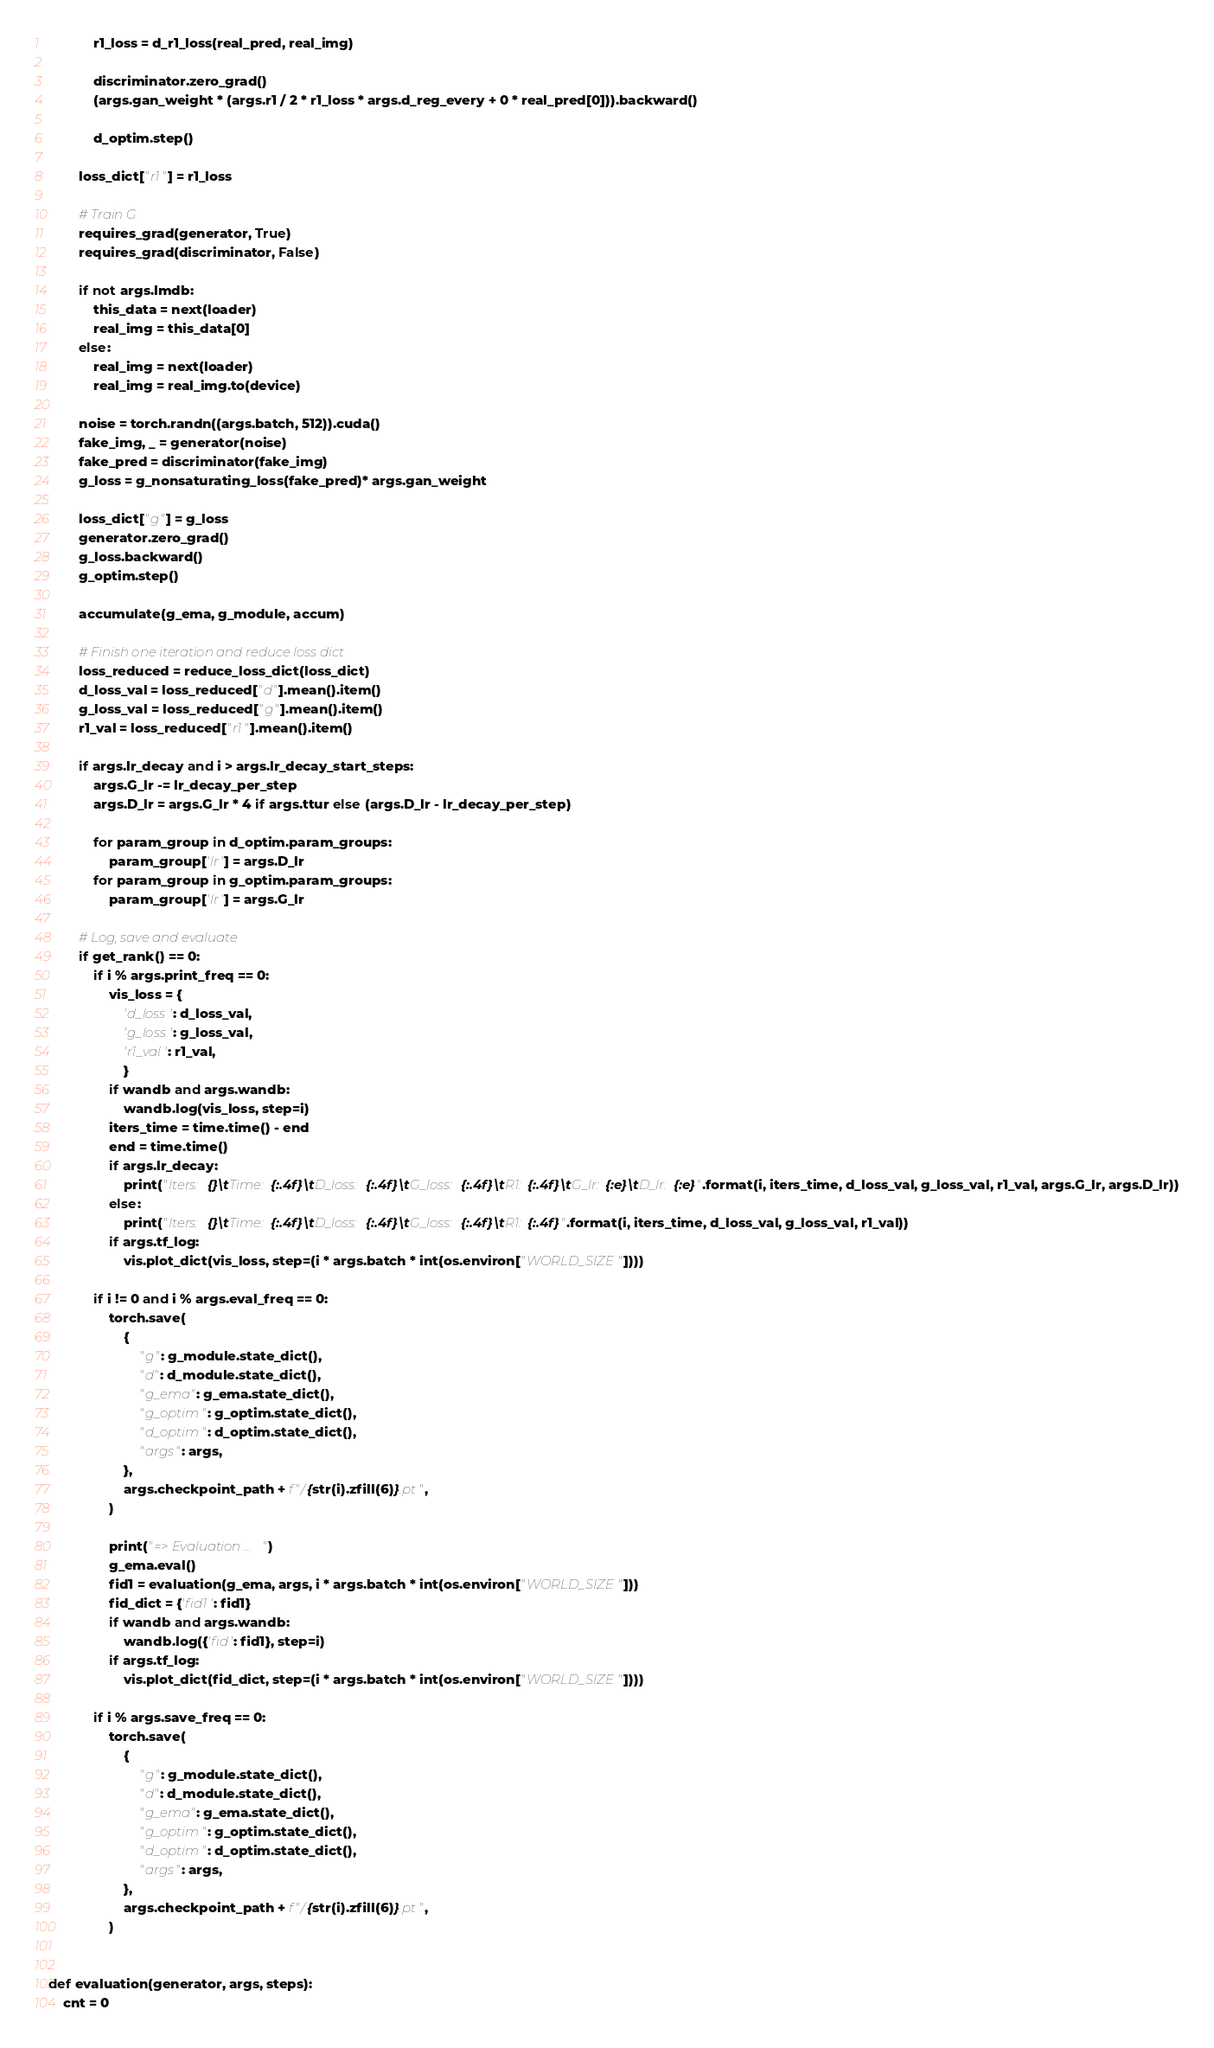<code> <loc_0><loc_0><loc_500><loc_500><_Python_>            r1_loss = d_r1_loss(real_pred, real_img)

            discriminator.zero_grad()
            (args.gan_weight * (args.r1 / 2 * r1_loss * args.d_reg_every + 0 * real_pred[0])).backward()

            d_optim.step()

        loss_dict["r1"] = r1_loss

        # Train G
        requires_grad(generator, True)
        requires_grad(discriminator, False)

        if not args.lmdb:
            this_data = next(loader)
            real_img = this_data[0]
        else:
            real_img = next(loader)
            real_img = real_img.to(device)

        noise = torch.randn((args.batch, 512)).cuda()
        fake_img, _ = generator(noise)
        fake_pred = discriminator(fake_img)
        g_loss = g_nonsaturating_loss(fake_pred)* args.gan_weight

        loss_dict["g"] = g_loss
        generator.zero_grad()
        g_loss.backward()
        g_optim.step()

        accumulate(g_ema, g_module, accum)

        # Finish one iteration and reduce loss dict
        loss_reduced = reduce_loss_dict(loss_dict)
        d_loss_val = loss_reduced["d"].mean().item()
        g_loss_val = loss_reduced["g"].mean().item()
        r1_val = loss_reduced["r1"].mean().item()

        if args.lr_decay and i > args.lr_decay_start_steps:
            args.G_lr -= lr_decay_per_step
            args.D_lr = args.G_lr * 4 if args.ttur else (args.D_lr - lr_decay_per_step)
        
            for param_group in d_optim.param_groups:
                param_group['lr'] = args.D_lr
            for param_group in g_optim.param_groups:
                param_group['lr'] = args.G_lr

        # Log, save and evaluate
        if get_rank() == 0:
            if i % args.print_freq == 0:
                vis_loss = {
                    'd_loss': d_loss_val,
                    'g_loss': g_loss_val,
                    'r1_val': r1_val,
                    }
                if wandb and args.wandb:
                    wandb.log(vis_loss, step=i)
                iters_time = time.time() - end
                end = time.time()
                if args.lr_decay:
                    print("Iters: {}\tTime: {:.4f}\tD_loss: {:.4f}\tG_loss: {:.4f}\tR1: {:.4f}\tG_lr: {:e}\tD_lr: {:e}".format(i, iters_time, d_loss_val, g_loss_val, r1_val, args.G_lr, args.D_lr))
                else:
                    print("Iters: {}\tTime: {:.4f}\tD_loss: {:.4f}\tG_loss: {:.4f}\tR1: {:.4f}".format(i, iters_time, d_loss_val, g_loss_val, r1_val))
                if args.tf_log:
                    vis.plot_dict(vis_loss, step=(i * args.batch * int(os.environ["WORLD_SIZE"])))

            if i != 0 and i % args.eval_freq == 0:
                torch.save(
                    {
                        "g": g_module.state_dict(),
                        "d": d_module.state_dict(),
                        "g_ema": g_ema.state_dict(),
                        "g_optim": g_optim.state_dict(),
                        "d_optim": d_optim.state_dict(),
                        "args": args,
                    },
                    args.checkpoint_path + f"/{str(i).zfill(6)}.pt",
                )
                
                print("=> Evaluation ...")
                g_ema.eval()
                fid1 = evaluation(g_ema, args, i * args.batch * int(os.environ["WORLD_SIZE"]))
                fid_dict = {'fid1': fid1}
                if wandb and args.wandb:
                    wandb.log({'fid': fid1}, step=i)
                if args.tf_log:
                    vis.plot_dict(fid_dict, step=(i * args.batch * int(os.environ["WORLD_SIZE"])))

            if i % args.save_freq == 0:
                torch.save(
                    {
                        "g": g_module.state_dict(),
                        "d": d_module.state_dict(),
                        "g_ema": g_ema.state_dict(),
                        "g_optim": g_optim.state_dict(),
                        "d_optim": d_optim.state_dict(),
                        "args": args,
                    },
                    args.checkpoint_path + f"/{str(i).zfill(6)}.pt",
                )


def evaluation(generator, args, steps):
    cnt = 0
</code> 